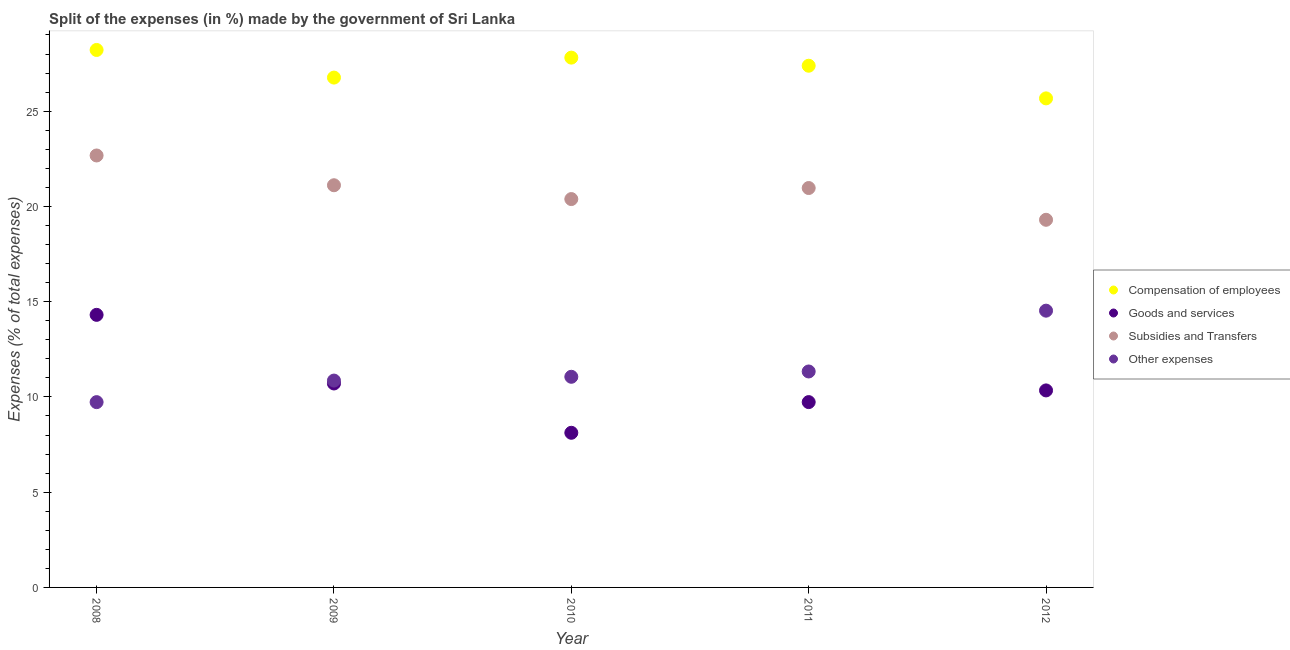What is the percentage of amount spent on goods and services in 2010?
Give a very brief answer. 8.12. Across all years, what is the maximum percentage of amount spent on compensation of employees?
Provide a short and direct response. 28.21. Across all years, what is the minimum percentage of amount spent on subsidies?
Your response must be concise. 19.3. What is the total percentage of amount spent on goods and services in the graph?
Ensure brevity in your answer.  53.2. What is the difference between the percentage of amount spent on compensation of employees in 2009 and that in 2011?
Provide a succinct answer. -0.62. What is the difference between the percentage of amount spent on subsidies in 2010 and the percentage of amount spent on compensation of employees in 2008?
Keep it short and to the point. -7.83. What is the average percentage of amount spent on subsidies per year?
Your answer should be compact. 20.89. In the year 2009, what is the difference between the percentage of amount spent on goods and services and percentage of amount spent on subsidies?
Your response must be concise. -10.41. In how many years, is the percentage of amount spent on goods and services greater than 27 %?
Your answer should be very brief. 0. What is the ratio of the percentage of amount spent on other expenses in 2009 to that in 2011?
Give a very brief answer. 0.96. Is the percentage of amount spent on compensation of employees in 2010 less than that in 2012?
Your answer should be very brief. No. Is the difference between the percentage of amount spent on goods and services in 2008 and 2011 greater than the difference between the percentage of amount spent on compensation of employees in 2008 and 2011?
Offer a very short reply. Yes. What is the difference between the highest and the second highest percentage of amount spent on compensation of employees?
Provide a succinct answer. 0.4. What is the difference between the highest and the lowest percentage of amount spent on other expenses?
Give a very brief answer. 4.8. In how many years, is the percentage of amount spent on compensation of employees greater than the average percentage of amount spent on compensation of employees taken over all years?
Your answer should be very brief. 3. Is the sum of the percentage of amount spent on other expenses in 2008 and 2012 greater than the maximum percentage of amount spent on goods and services across all years?
Provide a short and direct response. Yes. What is the difference between two consecutive major ticks on the Y-axis?
Ensure brevity in your answer.  5. Where does the legend appear in the graph?
Offer a very short reply. Center right. What is the title of the graph?
Provide a short and direct response. Split of the expenses (in %) made by the government of Sri Lanka. What is the label or title of the Y-axis?
Offer a very short reply. Expenses (% of total expenses). What is the Expenses (% of total expenses) of Compensation of employees in 2008?
Keep it short and to the point. 28.21. What is the Expenses (% of total expenses) in Goods and services in 2008?
Offer a very short reply. 14.31. What is the Expenses (% of total expenses) of Subsidies and Transfers in 2008?
Ensure brevity in your answer.  22.68. What is the Expenses (% of total expenses) in Other expenses in 2008?
Your response must be concise. 9.73. What is the Expenses (% of total expenses) in Compensation of employees in 2009?
Ensure brevity in your answer.  26.76. What is the Expenses (% of total expenses) in Goods and services in 2009?
Provide a short and direct response. 10.71. What is the Expenses (% of total expenses) of Subsidies and Transfers in 2009?
Keep it short and to the point. 21.11. What is the Expenses (% of total expenses) of Other expenses in 2009?
Your answer should be compact. 10.86. What is the Expenses (% of total expenses) in Compensation of employees in 2010?
Make the answer very short. 27.81. What is the Expenses (% of total expenses) in Goods and services in 2010?
Your response must be concise. 8.12. What is the Expenses (% of total expenses) in Subsidies and Transfers in 2010?
Provide a short and direct response. 20.39. What is the Expenses (% of total expenses) of Other expenses in 2010?
Provide a short and direct response. 11.06. What is the Expenses (% of total expenses) of Compensation of employees in 2011?
Your answer should be compact. 27.39. What is the Expenses (% of total expenses) in Goods and services in 2011?
Your answer should be compact. 9.73. What is the Expenses (% of total expenses) in Subsidies and Transfers in 2011?
Keep it short and to the point. 20.97. What is the Expenses (% of total expenses) in Other expenses in 2011?
Provide a short and direct response. 11.34. What is the Expenses (% of total expenses) of Compensation of employees in 2012?
Offer a very short reply. 25.67. What is the Expenses (% of total expenses) of Goods and services in 2012?
Keep it short and to the point. 10.34. What is the Expenses (% of total expenses) in Subsidies and Transfers in 2012?
Offer a very short reply. 19.3. What is the Expenses (% of total expenses) in Other expenses in 2012?
Your answer should be compact. 14.53. Across all years, what is the maximum Expenses (% of total expenses) of Compensation of employees?
Your response must be concise. 28.21. Across all years, what is the maximum Expenses (% of total expenses) in Goods and services?
Provide a short and direct response. 14.31. Across all years, what is the maximum Expenses (% of total expenses) in Subsidies and Transfers?
Offer a very short reply. 22.68. Across all years, what is the maximum Expenses (% of total expenses) in Other expenses?
Provide a succinct answer. 14.53. Across all years, what is the minimum Expenses (% of total expenses) of Compensation of employees?
Your answer should be compact. 25.67. Across all years, what is the minimum Expenses (% of total expenses) in Goods and services?
Make the answer very short. 8.12. Across all years, what is the minimum Expenses (% of total expenses) of Subsidies and Transfers?
Offer a terse response. 19.3. Across all years, what is the minimum Expenses (% of total expenses) of Other expenses?
Provide a short and direct response. 9.73. What is the total Expenses (% of total expenses) of Compensation of employees in the graph?
Offer a very short reply. 135.85. What is the total Expenses (% of total expenses) in Goods and services in the graph?
Ensure brevity in your answer.  53.2. What is the total Expenses (% of total expenses) in Subsidies and Transfers in the graph?
Offer a terse response. 104.44. What is the total Expenses (% of total expenses) in Other expenses in the graph?
Offer a very short reply. 57.51. What is the difference between the Expenses (% of total expenses) in Compensation of employees in 2008 and that in 2009?
Provide a succinct answer. 1.45. What is the difference between the Expenses (% of total expenses) in Goods and services in 2008 and that in 2009?
Make the answer very short. 3.6. What is the difference between the Expenses (% of total expenses) of Subsidies and Transfers in 2008 and that in 2009?
Ensure brevity in your answer.  1.56. What is the difference between the Expenses (% of total expenses) of Other expenses in 2008 and that in 2009?
Your answer should be compact. -1.13. What is the difference between the Expenses (% of total expenses) of Compensation of employees in 2008 and that in 2010?
Give a very brief answer. 0.4. What is the difference between the Expenses (% of total expenses) in Goods and services in 2008 and that in 2010?
Keep it short and to the point. 6.19. What is the difference between the Expenses (% of total expenses) in Subsidies and Transfers in 2008 and that in 2010?
Make the answer very short. 2.29. What is the difference between the Expenses (% of total expenses) in Other expenses in 2008 and that in 2010?
Offer a very short reply. -1.33. What is the difference between the Expenses (% of total expenses) of Compensation of employees in 2008 and that in 2011?
Provide a succinct answer. 0.83. What is the difference between the Expenses (% of total expenses) of Goods and services in 2008 and that in 2011?
Offer a terse response. 4.58. What is the difference between the Expenses (% of total expenses) of Subsidies and Transfers in 2008 and that in 2011?
Offer a terse response. 1.71. What is the difference between the Expenses (% of total expenses) in Other expenses in 2008 and that in 2011?
Offer a terse response. -1.61. What is the difference between the Expenses (% of total expenses) of Compensation of employees in 2008 and that in 2012?
Make the answer very short. 2.54. What is the difference between the Expenses (% of total expenses) in Goods and services in 2008 and that in 2012?
Your response must be concise. 3.97. What is the difference between the Expenses (% of total expenses) in Subsidies and Transfers in 2008 and that in 2012?
Your response must be concise. 3.38. What is the difference between the Expenses (% of total expenses) in Other expenses in 2008 and that in 2012?
Make the answer very short. -4.8. What is the difference between the Expenses (% of total expenses) of Compensation of employees in 2009 and that in 2010?
Offer a very short reply. -1.05. What is the difference between the Expenses (% of total expenses) in Goods and services in 2009 and that in 2010?
Your answer should be very brief. 2.59. What is the difference between the Expenses (% of total expenses) in Subsidies and Transfers in 2009 and that in 2010?
Offer a terse response. 0.73. What is the difference between the Expenses (% of total expenses) in Other expenses in 2009 and that in 2010?
Your response must be concise. -0.2. What is the difference between the Expenses (% of total expenses) in Compensation of employees in 2009 and that in 2011?
Offer a terse response. -0.62. What is the difference between the Expenses (% of total expenses) in Goods and services in 2009 and that in 2011?
Keep it short and to the point. 0.98. What is the difference between the Expenses (% of total expenses) of Subsidies and Transfers in 2009 and that in 2011?
Make the answer very short. 0.15. What is the difference between the Expenses (% of total expenses) of Other expenses in 2009 and that in 2011?
Your response must be concise. -0.48. What is the difference between the Expenses (% of total expenses) of Compensation of employees in 2009 and that in 2012?
Make the answer very short. 1.09. What is the difference between the Expenses (% of total expenses) in Goods and services in 2009 and that in 2012?
Make the answer very short. 0.36. What is the difference between the Expenses (% of total expenses) of Subsidies and Transfers in 2009 and that in 2012?
Offer a terse response. 1.81. What is the difference between the Expenses (% of total expenses) of Other expenses in 2009 and that in 2012?
Your answer should be compact. -3.67. What is the difference between the Expenses (% of total expenses) in Compensation of employees in 2010 and that in 2011?
Your answer should be very brief. 0.43. What is the difference between the Expenses (% of total expenses) of Goods and services in 2010 and that in 2011?
Make the answer very short. -1.61. What is the difference between the Expenses (% of total expenses) of Subsidies and Transfers in 2010 and that in 2011?
Your answer should be compact. -0.58. What is the difference between the Expenses (% of total expenses) of Other expenses in 2010 and that in 2011?
Provide a succinct answer. -0.28. What is the difference between the Expenses (% of total expenses) in Compensation of employees in 2010 and that in 2012?
Ensure brevity in your answer.  2.14. What is the difference between the Expenses (% of total expenses) of Goods and services in 2010 and that in 2012?
Offer a terse response. -2.22. What is the difference between the Expenses (% of total expenses) in Subsidies and Transfers in 2010 and that in 2012?
Offer a terse response. 1.09. What is the difference between the Expenses (% of total expenses) of Other expenses in 2010 and that in 2012?
Your response must be concise. -3.47. What is the difference between the Expenses (% of total expenses) in Compensation of employees in 2011 and that in 2012?
Provide a short and direct response. 1.71. What is the difference between the Expenses (% of total expenses) in Goods and services in 2011 and that in 2012?
Give a very brief answer. -0.61. What is the difference between the Expenses (% of total expenses) in Subsidies and Transfers in 2011 and that in 2012?
Offer a very short reply. 1.67. What is the difference between the Expenses (% of total expenses) of Other expenses in 2011 and that in 2012?
Your answer should be compact. -3.19. What is the difference between the Expenses (% of total expenses) in Compensation of employees in 2008 and the Expenses (% of total expenses) in Goods and services in 2009?
Give a very brief answer. 17.51. What is the difference between the Expenses (% of total expenses) in Compensation of employees in 2008 and the Expenses (% of total expenses) in Subsidies and Transfers in 2009?
Ensure brevity in your answer.  7.1. What is the difference between the Expenses (% of total expenses) of Compensation of employees in 2008 and the Expenses (% of total expenses) of Other expenses in 2009?
Your response must be concise. 17.36. What is the difference between the Expenses (% of total expenses) of Goods and services in 2008 and the Expenses (% of total expenses) of Subsidies and Transfers in 2009?
Offer a terse response. -6.8. What is the difference between the Expenses (% of total expenses) in Goods and services in 2008 and the Expenses (% of total expenses) in Other expenses in 2009?
Your answer should be compact. 3.45. What is the difference between the Expenses (% of total expenses) of Subsidies and Transfers in 2008 and the Expenses (% of total expenses) of Other expenses in 2009?
Provide a short and direct response. 11.82. What is the difference between the Expenses (% of total expenses) in Compensation of employees in 2008 and the Expenses (% of total expenses) in Goods and services in 2010?
Give a very brief answer. 20.1. What is the difference between the Expenses (% of total expenses) of Compensation of employees in 2008 and the Expenses (% of total expenses) of Subsidies and Transfers in 2010?
Ensure brevity in your answer.  7.83. What is the difference between the Expenses (% of total expenses) of Compensation of employees in 2008 and the Expenses (% of total expenses) of Other expenses in 2010?
Offer a terse response. 17.16. What is the difference between the Expenses (% of total expenses) of Goods and services in 2008 and the Expenses (% of total expenses) of Subsidies and Transfers in 2010?
Provide a short and direct response. -6.08. What is the difference between the Expenses (% of total expenses) in Goods and services in 2008 and the Expenses (% of total expenses) in Other expenses in 2010?
Make the answer very short. 3.25. What is the difference between the Expenses (% of total expenses) in Subsidies and Transfers in 2008 and the Expenses (% of total expenses) in Other expenses in 2010?
Offer a terse response. 11.62. What is the difference between the Expenses (% of total expenses) of Compensation of employees in 2008 and the Expenses (% of total expenses) of Goods and services in 2011?
Your answer should be compact. 18.49. What is the difference between the Expenses (% of total expenses) of Compensation of employees in 2008 and the Expenses (% of total expenses) of Subsidies and Transfers in 2011?
Offer a terse response. 7.25. What is the difference between the Expenses (% of total expenses) of Compensation of employees in 2008 and the Expenses (% of total expenses) of Other expenses in 2011?
Provide a short and direct response. 16.88. What is the difference between the Expenses (% of total expenses) of Goods and services in 2008 and the Expenses (% of total expenses) of Subsidies and Transfers in 2011?
Your answer should be very brief. -6.66. What is the difference between the Expenses (% of total expenses) in Goods and services in 2008 and the Expenses (% of total expenses) in Other expenses in 2011?
Your response must be concise. 2.97. What is the difference between the Expenses (% of total expenses) of Subsidies and Transfers in 2008 and the Expenses (% of total expenses) of Other expenses in 2011?
Your response must be concise. 11.34. What is the difference between the Expenses (% of total expenses) of Compensation of employees in 2008 and the Expenses (% of total expenses) of Goods and services in 2012?
Provide a short and direct response. 17.87. What is the difference between the Expenses (% of total expenses) of Compensation of employees in 2008 and the Expenses (% of total expenses) of Subsidies and Transfers in 2012?
Your response must be concise. 8.91. What is the difference between the Expenses (% of total expenses) of Compensation of employees in 2008 and the Expenses (% of total expenses) of Other expenses in 2012?
Your answer should be very brief. 13.69. What is the difference between the Expenses (% of total expenses) in Goods and services in 2008 and the Expenses (% of total expenses) in Subsidies and Transfers in 2012?
Your answer should be very brief. -4.99. What is the difference between the Expenses (% of total expenses) in Goods and services in 2008 and the Expenses (% of total expenses) in Other expenses in 2012?
Your answer should be compact. -0.22. What is the difference between the Expenses (% of total expenses) of Subsidies and Transfers in 2008 and the Expenses (% of total expenses) of Other expenses in 2012?
Provide a succinct answer. 8.15. What is the difference between the Expenses (% of total expenses) of Compensation of employees in 2009 and the Expenses (% of total expenses) of Goods and services in 2010?
Provide a short and direct response. 18.65. What is the difference between the Expenses (% of total expenses) of Compensation of employees in 2009 and the Expenses (% of total expenses) of Subsidies and Transfers in 2010?
Give a very brief answer. 6.38. What is the difference between the Expenses (% of total expenses) of Compensation of employees in 2009 and the Expenses (% of total expenses) of Other expenses in 2010?
Your answer should be compact. 15.71. What is the difference between the Expenses (% of total expenses) in Goods and services in 2009 and the Expenses (% of total expenses) in Subsidies and Transfers in 2010?
Give a very brief answer. -9.68. What is the difference between the Expenses (% of total expenses) of Goods and services in 2009 and the Expenses (% of total expenses) of Other expenses in 2010?
Make the answer very short. -0.35. What is the difference between the Expenses (% of total expenses) of Subsidies and Transfers in 2009 and the Expenses (% of total expenses) of Other expenses in 2010?
Provide a succinct answer. 10.05. What is the difference between the Expenses (% of total expenses) of Compensation of employees in 2009 and the Expenses (% of total expenses) of Goods and services in 2011?
Your answer should be compact. 17.04. What is the difference between the Expenses (% of total expenses) of Compensation of employees in 2009 and the Expenses (% of total expenses) of Subsidies and Transfers in 2011?
Give a very brief answer. 5.8. What is the difference between the Expenses (% of total expenses) in Compensation of employees in 2009 and the Expenses (% of total expenses) in Other expenses in 2011?
Offer a very short reply. 15.43. What is the difference between the Expenses (% of total expenses) of Goods and services in 2009 and the Expenses (% of total expenses) of Subsidies and Transfers in 2011?
Give a very brief answer. -10.26. What is the difference between the Expenses (% of total expenses) in Goods and services in 2009 and the Expenses (% of total expenses) in Other expenses in 2011?
Make the answer very short. -0.63. What is the difference between the Expenses (% of total expenses) of Subsidies and Transfers in 2009 and the Expenses (% of total expenses) of Other expenses in 2011?
Give a very brief answer. 9.78. What is the difference between the Expenses (% of total expenses) in Compensation of employees in 2009 and the Expenses (% of total expenses) in Goods and services in 2012?
Your answer should be compact. 16.42. What is the difference between the Expenses (% of total expenses) of Compensation of employees in 2009 and the Expenses (% of total expenses) of Subsidies and Transfers in 2012?
Provide a short and direct response. 7.46. What is the difference between the Expenses (% of total expenses) in Compensation of employees in 2009 and the Expenses (% of total expenses) in Other expenses in 2012?
Your response must be concise. 12.24. What is the difference between the Expenses (% of total expenses) in Goods and services in 2009 and the Expenses (% of total expenses) in Subsidies and Transfers in 2012?
Offer a very short reply. -8.59. What is the difference between the Expenses (% of total expenses) in Goods and services in 2009 and the Expenses (% of total expenses) in Other expenses in 2012?
Provide a succinct answer. -3.82. What is the difference between the Expenses (% of total expenses) in Subsidies and Transfers in 2009 and the Expenses (% of total expenses) in Other expenses in 2012?
Your answer should be compact. 6.58. What is the difference between the Expenses (% of total expenses) of Compensation of employees in 2010 and the Expenses (% of total expenses) of Goods and services in 2011?
Provide a short and direct response. 18.08. What is the difference between the Expenses (% of total expenses) of Compensation of employees in 2010 and the Expenses (% of total expenses) of Subsidies and Transfers in 2011?
Your answer should be very brief. 6.85. What is the difference between the Expenses (% of total expenses) in Compensation of employees in 2010 and the Expenses (% of total expenses) in Other expenses in 2011?
Your answer should be compact. 16.48. What is the difference between the Expenses (% of total expenses) of Goods and services in 2010 and the Expenses (% of total expenses) of Subsidies and Transfers in 2011?
Give a very brief answer. -12.85. What is the difference between the Expenses (% of total expenses) of Goods and services in 2010 and the Expenses (% of total expenses) of Other expenses in 2011?
Keep it short and to the point. -3.22. What is the difference between the Expenses (% of total expenses) of Subsidies and Transfers in 2010 and the Expenses (% of total expenses) of Other expenses in 2011?
Provide a succinct answer. 9.05. What is the difference between the Expenses (% of total expenses) of Compensation of employees in 2010 and the Expenses (% of total expenses) of Goods and services in 2012?
Offer a terse response. 17.47. What is the difference between the Expenses (% of total expenses) of Compensation of employees in 2010 and the Expenses (% of total expenses) of Subsidies and Transfers in 2012?
Your response must be concise. 8.51. What is the difference between the Expenses (% of total expenses) in Compensation of employees in 2010 and the Expenses (% of total expenses) in Other expenses in 2012?
Your response must be concise. 13.28. What is the difference between the Expenses (% of total expenses) of Goods and services in 2010 and the Expenses (% of total expenses) of Subsidies and Transfers in 2012?
Make the answer very short. -11.18. What is the difference between the Expenses (% of total expenses) in Goods and services in 2010 and the Expenses (% of total expenses) in Other expenses in 2012?
Your answer should be very brief. -6.41. What is the difference between the Expenses (% of total expenses) of Subsidies and Transfers in 2010 and the Expenses (% of total expenses) of Other expenses in 2012?
Provide a short and direct response. 5.86. What is the difference between the Expenses (% of total expenses) in Compensation of employees in 2011 and the Expenses (% of total expenses) in Goods and services in 2012?
Offer a terse response. 17.04. What is the difference between the Expenses (% of total expenses) in Compensation of employees in 2011 and the Expenses (% of total expenses) in Subsidies and Transfers in 2012?
Your answer should be very brief. 8.09. What is the difference between the Expenses (% of total expenses) of Compensation of employees in 2011 and the Expenses (% of total expenses) of Other expenses in 2012?
Offer a very short reply. 12.86. What is the difference between the Expenses (% of total expenses) in Goods and services in 2011 and the Expenses (% of total expenses) in Subsidies and Transfers in 2012?
Your answer should be very brief. -9.57. What is the difference between the Expenses (% of total expenses) in Subsidies and Transfers in 2011 and the Expenses (% of total expenses) in Other expenses in 2012?
Provide a succinct answer. 6.44. What is the average Expenses (% of total expenses) in Compensation of employees per year?
Give a very brief answer. 27.17. What is the average Expenses (% of total expenses) of Goods and services per year?
Make the answer very short. 10.64. What is the average Expenses (% of total expenses) in Subsidies and Transfers per year?
Ensure brevity in your answer.  20.89. What is the average Expenses (% of total expenses) in Other expenses per year?
Make the answer very short. 11.5. In the year 2008, what is the difference between the Expenses (% of total expenses) in Compensation of employees and Expenses (% of total expenses) in Goods and services?
Ensure brevity in your answer.  13.91. In the year 2008, what is the difference between the Expenses (% of total expenses) of Compensation of employees and Expenses (% of total expenses) of Subsidies and Transfers?
Your answer should be very brief. 5.54. In the year 2008, what is the difference between the Expenses (% of total expenses) in Compensation of employees and Expenses (% of total expenses) in Other expenses?
Ensure brevity in your answer.  18.49. In the year 2008, what is the difference between the Expenses (% of total expenses) of Goods and services and Expenses (% of total expenses) of Subsidies and Transfers?
Keep it short and to the point. -8.37. In the year 2008, what is the difference between the Expenses (% of total expenses) in Goods and services and Expenses (% of total expenses) in Other expenses?
Your answer should be compact. 4.58. In the year 2008, what is the difference between the Expenses (% of total expenses) in Subsidies and Transfers and Expenses (% of total expenses) in Other expenses?
Make the answer very short. 12.95. In the year 2009, what is the difference between the Expenses (% of total expenses) in Compensation of employees and Expenses (% of total expenses) in Goods and services?
Offer a very short reply. 16.06. In the year 2009, what is the difference between the Expenses (% of total expenses) of Compensation of employees and Expenses (% of total expenses) of Subsidies and Transfers?
Ensure brevity in your answer.  5.65. In the year 2009, what is the difference between the Expenses (% of total expenses) in Compensation of employees and Expenses (% of total expenses) in Other expenses?
Provide a short and direct response. 15.91. In the year 2009, what is the difference between the Expenses (% of total expenses) in Goods and services and Expenses (% of total expenses) in Subsidies and Transfers?
Provide a succinct answer. -10.41. In the year 2009, what is the difference between the Expenses (% of total expenses) in Goods and services and Expenses (% of total expenses) in Other expenses?
Offer a very short reply. -0.15. In the year 2009, what is the difference between the Expenses (% of total expenses) in Subsidies and Transfers and Expenses (% of total expenses) in Other expenses?
Provide a short and direct response. 10.25. In the year 2010, what is the difference between the Expenses (% of total expenses) of Compensation of employees and Expenses (% of total expenses) of Goods and services?
Ensure brevity in your answer.  19.69. In the year 2010, what is the difference between the Expenses (% of total expenses) in Compensation of employees and Expenses (% of total expenses) in Subsidies and Transfers?
Provide a short and direct response. 7.42. In the year 2010, what is the difference between the Expenses (% of total expenses) of Compensation of employees and Expenses (% of total expenses) of Other expenses?
Ensure brevity in your answer.  16.75. In the year 2010, what is the difference between the Expenses (% of total expenses) in Goods and services and Expenses (% of total expenses) in Subsidies and Transfers?
Make the answer very short. -12.27. In the year 2010, what is the difference between the Expenses (% of total expenses) in Goods and services and Expenses (% of total expenses) in Other expenses?
Your response must be concise. -2.94. In the year 2010, what is the difference between the Expenses (% of total expenses) in Subsidies and Transfers and Expenses (% of total expenses) in Other expenses?
Your answer should be very brief. 9.33. In the year 2011, what is the difference between the Expenses (% of total expenses) of Compensation of employees and Expenses (% of total expenses) of Goods and services?
Provide a short and direct response. 17.66. In the year 2011, what is the difference between the Expenses (% of total expenses) of Compensation of employees and Expenses (% of total expenses) of Subsidies and Transfers?
Offer a terse response. 6.42. In the year 2011, what is the difference between the Expenses (% of total expenses) of Compensation of employees and Expenses (% of total expenses) of Other expenses?
Keep it short and to the point. 16.05. In the year 2011, what is the difference between the Expenses (% of total expenses) in Goods and services and Expenses (% of total expenses) in Subsidies and Transfers?
Offer a very short reply. -11.24. In the year 2011, what is the difference between the Expenses (% of total expenses) in Goods and services and Expenses (% of total expenses) in Other expenses?
Provide a short and direct response. -1.61. In the year 2011, what is the difference between the Expenses (% of total expenses) of Subsidies and Transfers and Expenses (% of total expenses) of Other expenses?
Your answer should be compact. 9.63. In the year 2012, what is the difference between the Expenses (% of total expenses) of Compensation of employees and Expenses (% of total expenses) of Goods and services?
Make the answer very short. 15.33. In the year 2012, what is the difference between the Expenses (% of total expenses) in Compensation of employees and Expenses (% of total expenses) in Subsidies and Transfers?
Keep it short and to the point. 6.37. In the year 2012, what is the difference between the Expenses (% of total expenses) in Compensation of employees and Expenses (% of total expenses) in Other expenses?
Provide a succinct answer. 11.14. In the year 2012, what is the difference between the Expenses (% of total expenses) in Goods and services and Expenses (% of total expenses) in Subsidies and Transfers?
Offer a terse response. -8.96. In the year 2012, what is the difference between the Expenses (% of total expenses) of Goods and services and Expenses (% of total expenses) of Other expenses?
Give a very brief answer. -4.19. In the year 2012, what is the difference between the Expenses (% of total expenses) of Subsidies and Transfers and Expenses (% of total expenses) of Other expenses?
Ensure brevity in your answer.  4.77. What is the ratio of the Expenses (% of total expenses) in Compensation of employees in 2008 to that in 2009?
Provide a succinct answer. 1.05. What is the ratio of the Expenses (% of total expenses) in Goods and services in 2008 to that in 2009?
Your response must be concise. 1.34. What is the ratio of the Expenses (% of total expenses) in Subsidies and Transfers in 2008 to that in 2009?
Your answer should be very brief. 1.07. What is the ratio of the Expenses (% of total expenses) of Other expenses in 2008 to that in 2009?
Provide a short and direct response. 0.9. What is the ratio of the Expenses (% of total expenses) of Compensation of employees in 2008 to that in 2010?
Make the answer very short. 1.01. What is the ratio of the Expenses (% of total expenses) of Goods and services in 2008 to that in 2010?
Keep it short and to the point. 1.76. What is the ratio of the Expenses (% of total expenses) in Subsidies and Transfers in 2008 to that in 2010?
Keep it short and to the point. 1.11. What is the ratio of the Expenses (% of total expenses) of Other expenses in 2008 to that in 2010?
Provide a short and direct response. 0.88. What is the ratio of the Expenses (% of total expenses) of Compensation of employees in 2008 to that in 2011?
Ensure brevity in your answer.  1.03. What is the ratio of the Expenses (% of total expenses) in Goods and services in 2008 to that in 2011?
Your answer should be compact. 1.47. What is the ratio of the Expenses (% of total expenses) of Subsidies and Transfers in 2008 to that in 2011?
Provide a succinct answer. 1.08. What is the ratio of the Expenses (% of total expenses) in Other expenses in 2008 to that in 2011?
Make the answer very short. 0.86. What is the ratio of the Expenses (% of total expenses) in Compensation of employees in 2008 to that in 2012?
Give a very brief answer. 1.1. What is the ratio of the Expenses (% of total expenses) in Goods and services in 2008 to that in 2012?
Offer a very short reply. 1.38. What is the ratio of the Expenses (% of total expenses) of Subsidies and Transfers in 2008 to that in 2012?
Ensure brevity in your answer.  1.17. What is the ratio of the Expenses (% of total expenses) of Other expenses in 2008 to that in 2012?
Give a very brief answer. 0.67. What is the ratio of the Expenses (% of total expenses) in Compensation of employees in 2009 to that in 2010?
Your answer should be compact. 0.96. What is the ratio of the Expenses (% of total expenses) of Goods and services in 2009 to that in 2010?
Give a very brief answer. 1.32. What is the ratio of the Expenses (% of total expenses) of Subsidies and Transfers in 2009 to that in 2010?
Ensure brevity in your answer.  1.04. What is the ratio of the Expenses (% of total expenses) in Other expenses in 2009 to that in 2010?
Your answer should be very brief. 0.98. What is the ratio of the Expenses (% of total expenses) in Compensation of employees in 2009 to that in 2011?
Offer a very short reply. 0.98. What is the ratio of the Expenses (% of total expenses) of Goods and services in 2009 to that in 2011?
Your response must be concise. 1.1. What is the ratio of the Expenses (% of total expenses) of Subsidies and Transfers in 2009 to that in 2011?
Your answer should be compact. 1.01. What is the ratio of the Expenses (% of total expenses) of Other expenses in 2009 to that in 2011?
Keep it short and to the point. 0.96. What is the ratio of the Expenses (% of total expenses) in Compensation of employees in 2009 to that in 2012?
Provide a short and direct response. 1.04. What is the ratio of the Expenses (% of total expenses) of Goods and services in 2009 to that in 2012?
Your answer should be compact. 1.04. What is the ratio of the Expenses (% of total expenses) in Subsidies and Transfers in 2009 to that in 2012?
Provide a short and direct response. 1.09. What is the ratio of the Expenses (% of total expenses) in Other expenses in 2009 to that in 2012?
Give a very brief answer. 0.75. What is the ratio of the Expenses (% of total expenses) of Compensation of employees in 2010 to that in 2011?
Keep it short and to the point. 1.02. What is the ratio of the Expenses (% of total expenses) of Goods and services in 2010 to that in 2011?
Offer a terse response. 0.83. What is the ratio of the Expenses (% of total expenses) in Subsidies and Transfers in 2010 to that in 2011?
Your answer should be very brief. 0.97. What is the ratio of the Expenses (% of total expenses) in Other expenses in 2010 to that in 2011?
Your answer should be very brief. 0.98. What is the ratio of the Expenses (% of total expenses) in Compensation of employees in 2010 to that in 2012?
Provide a succinct answer. 1.08. What is the ratio of the Expenses (% of total expenses) of Goods and services in 2010 to that in 2012?
Ensure brevity in your answer.  0.78. What is the ratio of the Expenses (% of total expenses) in Subsidies and Transfers in 2010 to that in 2012?
Your answer should be compact. 1.06. What is the ratio of the Expenses (% of total expenses) of Other expenses in 2010 to that in 2012?
Your response must be concise. 0.76. What is the ratio of the Expenses (% of total expenses) in Compensation of employees in 2011 to that in 2012?
Your response must be concise. 1.07. What is the ratio of the Expenses (% of total expenses) in Goods and services in 2011 to that in 2012?
Offer a very short reply. 0.94. What is the ratio of the Expenses (% of total expenses) of Subsidies and Transfers in 2011 to that in 2012?
Make the answer very short. 1.09. What is the ratio of the Expenses (% of total expenses) in Other expenses in 2011 to that in 2012?
Provide a succinct answer. 0.78. What is the difference between the highest and the second highest Expenses (% of total expenses) of Compensation of employees?
Give a very brief answer. 0.4. What is the difference between the highest and the second highest Expenses (% of total expenses) in Goods and services?
Your response must be concise. 3.6. What is the difference between the highest and the second highest Expenses (% of total expenses) of Subsidies and Transfers?
Ensure brevity in your answer.  1.56. What is the difference between the highest and the second highest Expenses (% of total expenses) of Other expenses?
Ensure brevity in your answer.  3.19. What is the difference between the highest and the lowest Expenses (% of total expenses) of Compensation of employees?
Provide a short and direct response. 2.54. What is the difference between the highest and the lowest Expenses (% of total expenses) in Goods and services?
Ensure brevity in your answer.  6.19. What is the difference between the highest and the lowest Expenses (% of total expenses) of Subsidies and Transfers?
Your response must be concise. 3.38. What is the difference between the highest and the lowest Expenses (% of total expenses) in Other expenses?
Your answer should be very brief. 4.8. 